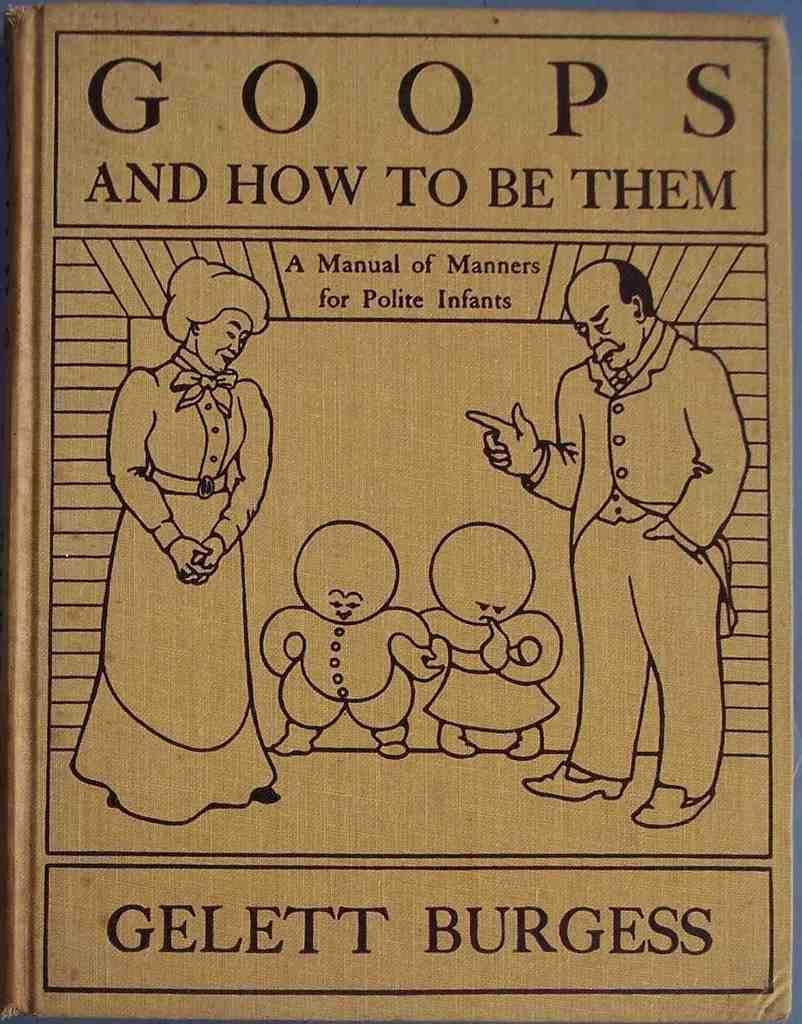What is featured in the picture? There is a poster in the picture. What type of content is on the poster? The poster contains diagrams and text. What type of canvas is used to create the poster in the image? There is no mention of a canvas in the provided facts, and the poster's material is not visible in the image. 